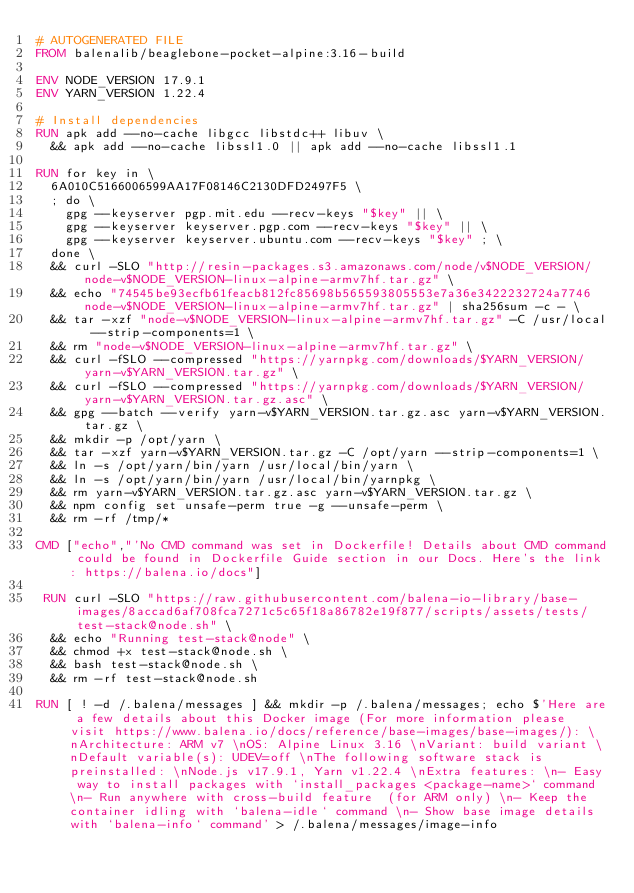<code> <loc_0><loc_0><loc_500><loc_500><_Dockerfile_># AUTOGENERATED FILE
FROM balenalib/beaglebone-pocket-alpine:3.16-build

ENV NODE_VERSION 17.9.1
ENV YARN_VERSION 1.22.4

# Install dependencies
RUN apk add --no-cache libgcc libstdc++ libuv \
	&& apk add --no-cache libssl1.0 || apk add --no-cache libssl1.1

RUN for key in \
	6A010C5166006599AA17F08146C2130DFD2497F5 \
	; do \
		gpg --keyserver pgp.mit.edu --recv-keys "$key" || \
		gpg --keyserver keyserver.pgp.com --recv-keys "$key" || \
		gpg --keyserver keyserver.ubuntu.com --recv-keys "$key" ; \
	done \
	&& curl -SLO "http://resin-packages.s3.amazonaws.com/node/v$NODE_VERSION/node-v$NODE_VERSION-linux-alpine-armv7hf.tar.gz" \
	&& echo "74545be93ecfb61feacb812fc85698b565593805553e7a36e3422232724a7746  node-v$NODE_VERSION-linux-alpine-armv7hf.tar.gz" | sha256sum -c - \
	&& tar -xzf "node-v$NODE_VERSION-linux-alpine-armv7hf.tar.gz" -C /usr/local --strip-components=1 \
	&& rm "node-v$NODE_VERSION-linux-alpine-armv7hf.tar.gz" \
	&& curl -fSLO --compressed "https://yarnpkg.com/downloads/$YARN_VERSION/yarn-v$YARN_VERSION.tar.gz" \
	&& curl -fSLO --compressed "https://yarnpkg.com/downloads/$YARN_VERSION/yarn-v$YARN_VERSION.tar.gz.asc" \
	&& gpg --batch --verify yarn-v$YARN_VERSION.tar.gz.asc yarn-v$YARN_VERSION.tar.gz \
	&& mkdir -p /opt/yarn \
	&& tar -xzf yarn-v$YARN_VERSION.tar.gz -C /opt/yarn --strip-components=1 \
	&& ln -s /opt/yarn/bin/yarn /usr/local/bin/yarn \
	&& ln -s /opt/yarn/bin/yarn /usr/local/bin/yarnpkg \
	&& rm yarn-v$YARN_VERSION.tar.gz.asc yarn-v$YARN_VERSION.tar.gz \
	&& npm config set unsafe-perm true -g --unsafe-perm \
	&& rm -rf /tmp/*

CMD ["echo","'No CMD command was set in Dockerfile! Details about CMD command could be found in Dockerfile Guide section in our Docs. Here's the link: https://balena.io/docs"]

 RUN curl -SLO "https://raw.githubusercontent.com/balena-io-library/base-images/8accad6af708fca7271c5c65f18a86782e19f877/scripts/assets/tests/test-stack@node.sh" \
  && echo "Running test-stack@node" \
  && chmod +x test-stack@node.sh \
  && bash test-stack@node.sh \
  && rm -rf test-stack@node.sh 

RUN [ ! -d /.balena/messages ] && mkdir -p /.balena/messages; echo $'Here are a few details about this Docker image (For more information please visit https://www.balena.io/docs/reference/base-images/base-images/): \nArchitecture: ARM v7 \nOS: Alpine Linux 3.16 \nVariant: build variant \nDefault variable(s): UDEV=off \nThe following software stack is preinstalled: \nNode.js v17.9.1, Yarn v1.22.4 \nExtra features: \n- Easy way to install packages with `install_packages <package-name>` command \n- Run anywhere with cross-build feature  (for ARM only) \n- Keep the container idling with `balena-idle` command \n- Show base image details with `balena-info` command' > /.balena/messages/image-info</code> 